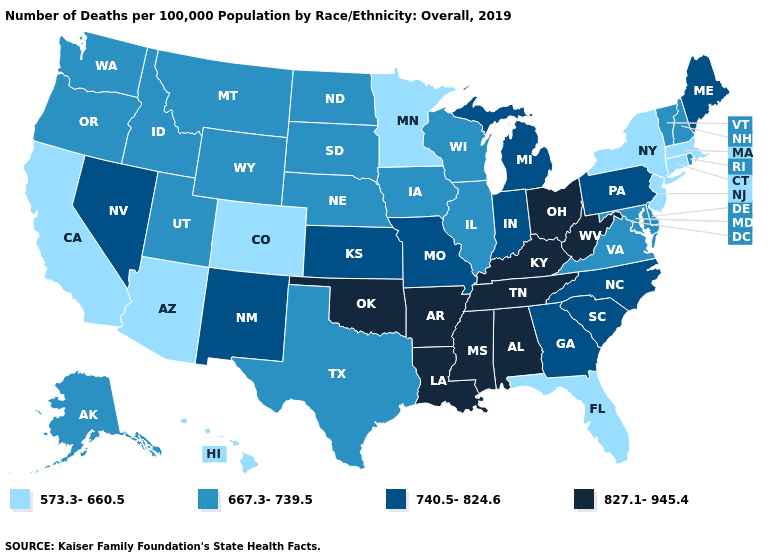Does the map have missing data?
Short answer required. No. Name the states that have a value in the range 667.3-739.5?
Be succinct. Alaska, Delaware, Idaho, Illinois, Iowa, Maryland, Montana, Nebraska, New Hampshire, North Dakota, Oregon, Rhode Island, South Dakota, Texas, Utah, Vermont, Virginia, Washington, Wisconsin, Wyoming. How many symbols are there in the legend?
Give a very brief answer. 4. What is the value of California?
Write a very short answer. 573.3-660.5. What is the value of Oregon?
Short answer required. 667.3-739.5. Is the legend a continuous bar?
Be succinct. No. What is the value of Texas?
Give a very brief answer. 667.3-739.5. Among the states that border Louisiana , does Texas have the lowest value?
Write a very short answer. Yes. What is the value of Hawaii?
Quick response, please. 573.3-660.5. What is the lowest value in states that border North Carolina?
Keep it brief. 667.3-739.5. Name the states that have a value in the range 827.1-945.4?
Give a very brief answer. Alabama, Arkansas, Kentucky, Louisiana, Mississippi, Ohio, Oklahoma, Tennessee, West Virginia. Does South Carolina have a lower value than Louisiana?
Write a very short answer. Yes. Does New Hampshire have a higher value than Colorado?
Quick response, please. Yes. Among the states that border South Carolina , which have the lowest value?
Concise answer only. Georgia, North Carolina. Name the states that have a value in the range 573.3-660.5?
Be succinct. Arizona, California, Colorado, Connecticut, Florida, Hawaii, Massachusetts, Minnesota, New Jersey, New York. 